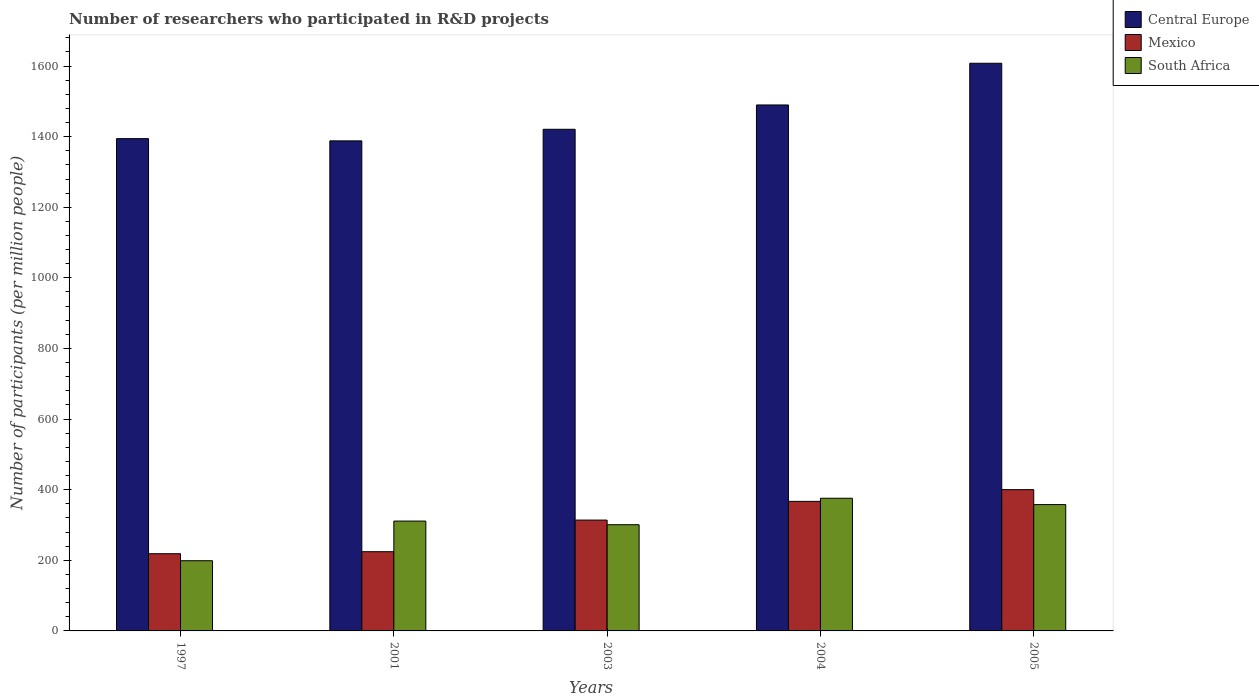How many different coloured bars are there?
Give a very brief answer. 3. How many groups of bars are there?
Your answer should be compact. 5. Are the number of bars on each tick of the X-axis equal?
Provide a succinct answer. Yes. How many bars are there on the 2nd tick from the left?
Your response must be concise. 3. How many bars are there on the 4th tick from the right?
Your answer should be very brief. 3. In how many cases, is the number of bars for a given year not equal to the number of legend labels?
Ensure brevity in your answer.  0. What is the number of researchers who participated in R&D projects in Mexico in 2005?
Ensure brevity in your answer.  400.21. Across all years, what is the maximum number of researchers who participated in R&D projects in Central Europe?
Keep it short and to the point. 1607.88. Across all years, what is the minimum number of researchers who participated in R&D projects in Central Europe?
Your answer should be very brief. 1388.07. In which year was the number of researchers who participated in R&D projects in Central Europe minimum?
Your response must be concise. 2001. What is the total number of researchers who participated in R&D projects in South Africa in the graph?
Ensure brevity in your answer.  1544.47. What is the difference between the number of researchers who participated in R&D projects in Mexico in 2001 and that in 2005?
Keep it short and to the point. -175.82. What is the difference between the number of researchers who participated in R&D projects in Central Europe in 2005 and the number of researchers who participated in R&D projects in Mexico in 2004?
Your answer should be compact. 1240.95. What is the average number of researchers who participated in R&D projects in Central Europe per year?
Your answer should be compact. 1460.2. In the year 2005, what is the difference between the number of researchers who participated in R&D projects in South Africa and number of researchers who participated in R&D projects in Central Europe?
Provide a short and direct response. -1250.04. In how many years, is the number of researchers who participated in R&D projects in South Africa greater than 240?
Offer a very short reply. 4. What is the ratio of the number of researchers who participated in R&D projects in South Africa in 2004 to that in 2005?
Your response must be concise. 1.05. Is the difference between the number of researchers who participated in R&D projects in South Africa in 1997 and 2001 greater than the difference between the number of researchers who participated in R&D projects in Central Europe in 1997 and 2001?
Your answer should be compact. No. What is the difference between the highest and the second highest number of researchers who participated in R&D projects in Mexico?
Provide a succinct answer. 33.27. What is the difference between the highest and the lowest number of researchers who participated in R&D projects in Central Europe?
Provide a succinct answer. 219.82. What does the 1st bar from the left in 2001 represents?
Your answer should be very brief. Central Europe. What does the 3rd bar from the right in 1997 represents?
Make the answer very short. Central Europe. How many bars are there?
Offer a very short reply. 15. Are all the bars in the graph horizontal?
Keep it short and to the point. No. How many years are there in the graph?
Keep it short and to the point. 5. What is the difference between two consecutive major ticks on the Y-axis?
Offer a terse response. 200. How many legend labels are there?
Your answer should be compact. 3. What is the title of the graph?
Provide a short and direct response. Number of researchers who participated in R&D projects. What is the label or title of the X-axis?
Give a very brief answer. Years. What is the label or title of the Y-axis?
Your answer should be compact. Number of participants (per million people). What is the Number of participants (per million people) in Central Europe in 1997?
Your answer should be compact. 1394.4. What is the Number of participants (per million people) of Mexico in 1997?
Your answer should be very brief. 218.71. What is the Number of participants (per million people) of South Africa in 1997?
Keep it short and to the point. 198.8. What is the Number of participants (per million people) of Central Europe in 2001?
Give a very brief answer. 1388.07. What is the Number of participants (per million people) in Mexico in 2001?
Make the answer very short. 224.39. What is the Number of participants (per million people) of South Africa in 2001?
Make the answer very short. 311.15. What is the Number of participants (per million people) in Central Europe in 2003?
Offer a very short reply. 1420.86. What is the Number of participants (per million people) of Mexico in 2003?
Give a very brief answer. 313.95. What is the Number of participants (per million people) in South Africa in 2003?
Offer a terse response. 300.84. What is the Number of participants (per million people) of Central Europe in 2004?
Provide a short and direct response. 1489.77. What is the Number of participants (per million people) in Mexico in 2004?
Provide a short and direct response. 366.94. What is the Number of participants (per million people) of South Africa in 2004?
Your answer should be very brief. 375.83. What is the Number of participants (per million people) of Central Europe in 2005?
Make the answer very short. 1607.88. What is the Number of participants (per million people) of Mexico in 2005?
Your answer should be very brief. 400.21. What is the Number of participants (per million people) in South Africa in 2005?
Offer a very short reply. 357.85. Across all years, what is the maximum Number of participants (per million people) in Central Europe?
Provide a short and direct response. 1607.88. Across all years, what is the maximum Number of participants (per million people) of Mexico?
Provide a short and direct response. 400.21. Across all years, what is the maximum Number of participants (per million people) of South Africa?
Ensure brevity in your answer.  375.83. Across all years, what is the minimum Number of participants (per million people) of Central Europe?
Ensure brevity in your answer.  1388.07. Across all years, what is the minimum Number of participants (per million people) in Mexico?
Keep it short and to the point. 218.71. Across all years, what is the minimum Number of participants (per million people) in South Africa?
Your response must be concise. 198.8. What is the total Number of participants (per million people) of Central Europe in the graph?
Provide a short and direct response. 7300.98. What is the total Number of participants (per million people) of Mexico in the graph?
Give a very brief answer. 1524.2. What is the total Number of participants (per million people) in South Africa in the graph?
Offer a terse response. 1544.47. What is the difference between the Number of participants (per million people) in Central Europe in 1997 and that in 2001?
Provide a succinct answer. 6.33. What is the difference between the Number of participants (per million people) in Mexico in 1997 and that in 2001?
Provide a succinct answer. -5.68. What is the difference between the Number of participants (per million people) in South Africa in 1997 and that in 2001?
Provide a short and direct response. -112.35. What is the difference between the Number of participants (per million people) of Central Europe in 1997 and that in 2003?
Your response must be concise. -26.46. What is the difference between the Number of participants (per million people) in Mexico in 1997 and that in 2003?
Offer a very short reply. -95.25. What is the difference between the Number of participants (per million people) in South Africa in 1997 and that in 2003?
Your answer should be compact. -102.04. What is the difference between the Number of participants (per million people) in Central Europe in 1997 and that in 2004?
Your response must be concise. -95.37. What is the difference between the Number of participants (per million people) of Mexico in 1997 and that in 2004?
Offer a very short reply. -148.23. What is the difference between the Number of participants (per million people) in South Africa in 1997 and that in 2004?
Give a very brief answer. -177.02. What is the difference between the Number of participants (per million people) in Central Europe in 1997 and that in 2005?
Offer a very short reply. -213.49. What is the difference between the Number of participants (per million people) in Mexico in 1997 and that in 2005?
Your answer should be very brief. -181.5. What is the difference between the Number of participants (per million people) in South Africa in 1997 and that in 2005?
Give a very brief answer. -159.04. What is the difference between the Number of participants (per million people) of Central Europe in 2001 and that in 2003?
Keep it short and to the point. -32.79. What is the difference between the Number of participants (per million people) of Mexico in 2001 and that in 2003?
Your response must be concise. -89.56. What is the difference between the Number of participants (per million people) of South Africa in 2001 and that in 2003?
Keep it short and to the point. 10.31. What is the difference between the Number of participants (per million people) in Central Europe in 2001 and that in 2004?
Provide a short and direct response. -101.7. What is the difference between the Number of participants (per million people) in Mexico in 2001 and that in 2004?
Offer a very short reply. -142.55. What is the difference between the Number of participants (per million people) of South Africa in 2001 and that in 2004?
Offer a very short reply. -64.67. What is the difference between the Number of participants (per million people) of Central Europe in 2001 and that in 2005?
Your answer should be compact. -219.82. What is the difference between the Number of participants (per million people) of Mexico in 2001 and that in 2005?
Offer a very short reply. -175.82. What is the difference between the Number of participants (per million people) of South Africa in 2001 and that in 2005?
Offer a terse response. -46.7. What is the difference between the Number of participants (per million people) of Central Europe in 2003 and that in 2004?
Your answer should be very brief. -68.92. What is the difference between the Number of participants (per million people) in Mexico in 2003 and that in 2004?
Give a very brief answer. -52.99. What is the difference between the Number of participants (per million people) of South Africa in 2003 and that in 2004?
Make the answer very short. -74.98. What is the difference between the Number of participants (per million people) in Central Europe in 2003 and that in 2005?
Keep it short and to the point. -187.03. What is the difference between the Number of participants (per million people) of Mexico in 2003 and that in 2005?
Ensure brevity in your answer.  -86.25. What is the difference between the Number of participants (per million people) of South Africa in 2003 and that in 2005?
Provide a succinct answer. -57.01. What is the difference between the Number of participants (per million people) in Central Europe in 2004 and that in 2005?
Make the answer very short. -118.11. What is the difference between the Number of participants (per million people) in Mexico in 2004 and that in 2005?
Your answer should be very brief. -33.27. What is the difference between the Number of participants (per million people) of South Africa in 2004 and that in 2005?
Offer a very short reply. 17.98. What is the difference between the Number of participants (per million people) of Central Europe in 1997 and the Number of participants (per million people) of Mexico in 2001?
Provide a succinct answer. 1170.01. What is the difference between the Number of participants (per million people) of Central Europe in 1997 and the Number of participants (per million people) of South Africa in 2001?
Ensure brevity in your answer.  1083.25. What is the difference between the Number of participants (per million people) of Mexico in 1997 and the Number of participants (per million people) of South Africa in 2001?
Provide a short and direct response. -92.44. What is the difference between the Number of participants (per million people) in Central Europe in 1997 and the Number of participants (per million people) in Mexico in 2003?
Offer a terse response. 1080.44. What is the difference between the Number of participants (per million people) in Central Europe in 1997 and the Number of participants (per million people) in South Africa in 2003?
Ensure brevity in your answer.  1093.56. What is the difference between the Number of participants (per million people) in Mexico in 1997 and the Number of participants (per million people) in South Africa in 2003?
Your answer should be compact. -82.14. What is the difference between the Number of participants (per million people) in Central Europe in 1997 and the Number of participants (per million people) in Mexico in 2004?
Your response must be concise. 1027.46. What is the difference between the Number of participants (per million people) of Central Europe in 1997 and the Number of participants (per million people) of South Africa in 2004?
Provide a succinct answer. 1018.57. What is the difference between the Number of participants (per million people) of Mexico in 1997 and the Number of participants (per million people) of South Africa in 2004?
Ensure brevity in your answer.  -157.12. What is the difference between the Number of participants (per million people) of Central Europe in 1997 and the Number of participants (per million people) of Mexico in 2005?
Ensure brevity in your answer.  994.19. What is the difference between the Number of participants (per million people) in Central Europe in 1997 and the Number of participants (per million people) in South Africa in 2005?
Give a very brief answer. 1036.55. What is the difference between the Number of participants (per million people) in Mexico in 1997 and the Number of participants (per million people) in South Africa in 2005?
Offer a terse response. -139.14. What is the difference between the Number of participants (per million people) of Central Europe in 2001 and the Number of participants (per million people) of Mexico in 2003?
Your response must be concise. 1074.11. What is the difference between the Number of participants (per million people) in Central Europe in 2001 and the Number of participants (per million people) in South Africa in 2003?
Keep it short and to the point. 1087.23. What is the difference between the Number of participants (per million people) in Mexico in 2001 and the Number of participants (per million people) in South Africa in 2003?
Your answer should be compact. -76.45. What is the difference between the Number of participants (per million people) of Central Europe in 2001 and the Number of participants (per million people) of Mexico in 2004?
Offer a terse response. 1021.13. What is the difference between the Number of participants (per million people) of Central Europe in 2001 and the Number of participants (per million people) of South Africa in 2004?
Your response must be concise. 1012.24. What is the difference between the Number of participants (per million people) of Mexico in 2001 and the Number of participants (per million people) of South Africa in 2004?
Provide a short and direct response. -151.44. What is the difference between the Number of participants (per million people) of Central Europe in 2001 and the Number of participants (per million people) of Mexico in 2005?
Your answer should be very brief. 987.86. What is the difference between the Number of participants (per million people) of Central Europe in 2001 and the Number of participants (per million people) of South Africa in 2005?
Make the answer very short. 1030.22. What is the difference between the Number of participants (per million people) of Mexico in 2001 and the Number of participants (per million people) of South Africa in 2005?
Your answer should be compact. -133.46. What is the difference between the Number of participants (per million people) in Central Europe in 2003 and the Number of participants (per million people) in Mexico in 2004?
Give a very brief answer. 1053.92. What is the difference between the Number of participants (per million people) in Central Europe in 2003 and the Number of participants (per million people) in South Africa in 2004?
Ensure brevity in your answer.  1045.03. What is the difference between the Number of participants (per million people) in Mexico in 2003 and the Number of participants (per million people) in South Africa in 2004?
Provide a succinct answer. -61.87. What is the difference between the Number of participants (per million people) of Central Europe in 2003 and the Number of participants (per million people) of Mexico in 2005?
Offer a very short reply. 1020.65. What is the difference between the Number of participants (per million people) of Central Europe in 2003 and the Number of participants (per million people) of South Africa in 2005?
Your answer should be very brief. 1063.01. What is the difference between the Number of participants (per million people) in Mexico in 2003 and the Number of participants (per million people) in South Africa in 2005?
Provide a succinct answer. -43.89. What is the difference between the Number of participants (per million people) in Central Europe in 2004 and the Number of participants (per million people) in Mexico in 2005?
Provide a succinct answer. 1089.56. What is the difference between the Number of participants (per million people) of Central Europe in 2004 and the Number of participants (per million people) of South Africa in 2005?
Ensure brevity in your answer.  1131.92. What is the difference between the Number of participants (per million people) of Mexico in 2004 and the Number of participants (per million people) of South Africa in 2005?
Make the answer very short. 9.09. What is the average Number of participants (per million people) of Central Europe per year?
Keep it short and to the point. 1460.2. What is the average Number of participants (per million people) in Mexico per year?
Your response must be concise. 304.84. What is the average Number of participants (per million people) in South Africa per year?
Your response must be concise. 308.89. In the year 1997, what is the difference between the Number of participants (per million people) in Central Europe and Number of participants (per million people) in Mexico?
Provide a succinct answer. 1175.69. In the year 1997, what is the difference between the Number of participants (per million people) of Central Europe and Number of participants (per million people) of South Africa?
Provide a succinct answer. 1195.59. In the year 1997, what is the difference between the Number of participants (per million people) in Mexico and Number of participants (per million people) in South Africa?
Your response must be concise. 19.9. In the year 2001, what is the difference between the Number of participants (per million people) of Central Europe and Number of participants (per million people) of Mexico?
Provide a succinct answer. 1163.68. In the year 2001, what is the difference between the Number of participants (per million people) of Central Europe and Number of participants (per million people) of South Africa?
Give a very brief answer. 1076.92. In the year 2001, what is the difference between the Number of participants (per million people) in Mexico and Number of participants (per million people) in South Africa?
Your answer should be very brief. -86.76. In the year 2003, what is the difference between the Number of participants (per million people) of Central Europe and Number of participants (per million people) of Mexico?
Keep it short and to the point. 1106.9. In the year 2003, what is the difference between the Number of participants (per million people) in Central Europe and Number of participants (per million people) in South Africa?
Give a very brief answer. 1120.01. In the year 2003, what is the difference between the Number of participants (per million people) of Mexico and Number of participants (per million people) of South Africa?
Offer a very short reply. 13.11. In the year 2004, what is the difference between the Number of participants (per million people) in Central Europe and Number of participants (per million people) in Mexico?
Your answer should be very brief. 1122.83. In the year 2004, what is the difference between the Number of participants (per million people) in Central Europe and Number of participants (per million people) in South Africa?
Provide a succinct answer. 1113.95. In the year 2004, what is the difference between the Number of participants (per million people) of Mexico and Number of participants (per million people) of South Africa?
Offer a terse response. -8.89. In the year 2005, what is the difference between the Number of participants (per million people) of Central Europe and Number of participants (per million people) of Mexico?
Give a very brief answer. 1207.68. In the year 2005, what is the difference between the Number of participants (per million people) in Central Europe and Number of participants (per million people) in South Africa?
Your response must be concise. 1250.04. In the year 2005, what is the difference between the Number of participants (per million people) in Mexico and Number of participants (per million people) in South Africa?
Keep it short and to the point. 42.36. What is the ratio of the Number of participants (per million people) of Central Europe in 1997 to that in 2001?
Give a very brief answer. 1. What is the ratio of the Number of participants (per million people) in Mexico in 1997 to that in 2001?
Your answer should be compact. 0.97. What is the ratio of the Number of participants (per million people) in South Africa in 1997 to that in 2001?
Offer a terse response. 0.64. What is the ratio of the Number of participants (per million people) of Central Europe in 1997 to that in 2003?
Your answer should be compact. 0.98. What is the ratio of the Number of participants (per million people) in Mexico in 1997 to that in 2003?
Give a very brief answer. 0.7. What is the ratio of the Number of participants (per million people) of South Africa in 1997 to that in 2003?
Your response must be concise. 0.66. What is the ratio of the Number of participants (per million people) in Central Europe in 1997 to that in 2004?
Make the answer very short. 0.94. What is the ratio of the Number of participants (per million people) in Mexico in 1997 to that in 2004?
Provide a short and direct response. 0.6. What is the ratio of the Number of participants (per million people) of South Africa in 1997 to that in 2004?
Offer a terse response. 0.53. What is the ratio of the Number of participants (per million people) in Central Europe in 1997 to that in 2005?
Ensure brevity in your answer.  0.87. What is the ratio of the Number of participants (per million people) of Mexico in 1997 to that in 2005?
Ensure brevity in your answer.  0.55. What is the ratio of the Number of participants (per million people) of South Africa in 1997 to that in 2005?
Make the answer very short. 0.56. What is the ratio of the Number of participants (per million people) in Central Europe in 2001 to that in 2003?
Offer a terse response. 0.98. What is the ratio of the Number of participants (per million people) in Mexico in 2001 to that in 2003?
Your answer should be very brief. 0.71. What is the ratio of the Number of participants (per million people) of South Africa in 2001 to that in 2003?
Your answer should be very brief. 1.03. What is the ratio of the Number of participants (per million people) in Central Europe in 2001 to that in 2004?
Make the answer very short. 0.93. What is the ratio of the Number of participants (per million people) in Mexico in 2001 to that in 2004?
Ensure brevity in your answer.  0.61. What is the ratio of the Number of participants (per million people) of South Africa in 2001 to that in 2004?
Your response must be concise. 0.83. What is the ratio of the Number of participants (per million people) of Central Europe in 2001 to that in 2005?
Keep it short and to the point. 0.86. What is the ratio of the Number of participants (per million people) in Mexico in 2001 to that in 2005?
Offer a very short reply. 0.56. What is the ratio of the Number of participants (per million people) of South Africa in 2001 to that in 2005?
Your answer should be compact. 0.87. What is the ratio of the Number of participants (per million people) of Central Europe in 2003 to that in 2004?
Provide a short and direct response. 0.95. What is the ratio of the Number of participants (per million people) in Mexico in 2003 to that in 2004?
Provide a short and direct response. 0.86. What is the ratio of the Number of participants (per million people) of South Africa in 2003 to that in 2004?
Provide a short and direct response. 0.8. What is the ratio of the Number of participants (per million people) in Central Europe in 2003 to that in 2005?
Your answer should be very brief. 0.88. What is the ratio of the Number of participants (per million people) in Mexico in 2003 to that in 2005?
Offer a very short reply. 0.78. What is the ratio of the Number of participants (per million people) of South Africa in 2003 to that in 2005?
Keep it short and to the point. 0.84. What is the ratio of the Number of participants (per million people) in Central Europe in 2004 to that in 2005?
Your answer should be compact. 0.93. What is the ratio of the Number of participants (per million people) in Mexico in 2004 to that in 2005?
Ensure brevity in your answer.  0.92. What is the ratio of the Number of participants (per million people) of South Africa in 2004 to that in 2005?
Offer a very short reply. 1.05. What is the difference between the highest and the second highest Number of participants (per million people) of Central Europe?
Your answer should be compact. 118.11. What is the difference between the highest and the second highest Number of participants (per million people) of Mexico?
Offer a very short reply. 33.27. What is the difference between the highest and the second highest Number of participants (per million people) of South Africa?
Your answer should be very brief. 17.98. What is the difference between the highest and the lowest Number of participants (per million people) in Central Europe?
Give a very brief answer. 219.82. What is the difference between the highest and the lowest Number of participants (per million people) in Mexico?
Make the answer very short. 181.5. What is the difference between the highest and the lowest Number of participants (per million people) of South Africa?
Your response must be concise. 177.02. 